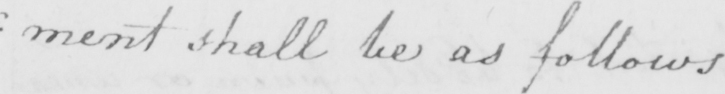What is written in this line of handwriting? : ment shall be as follows 